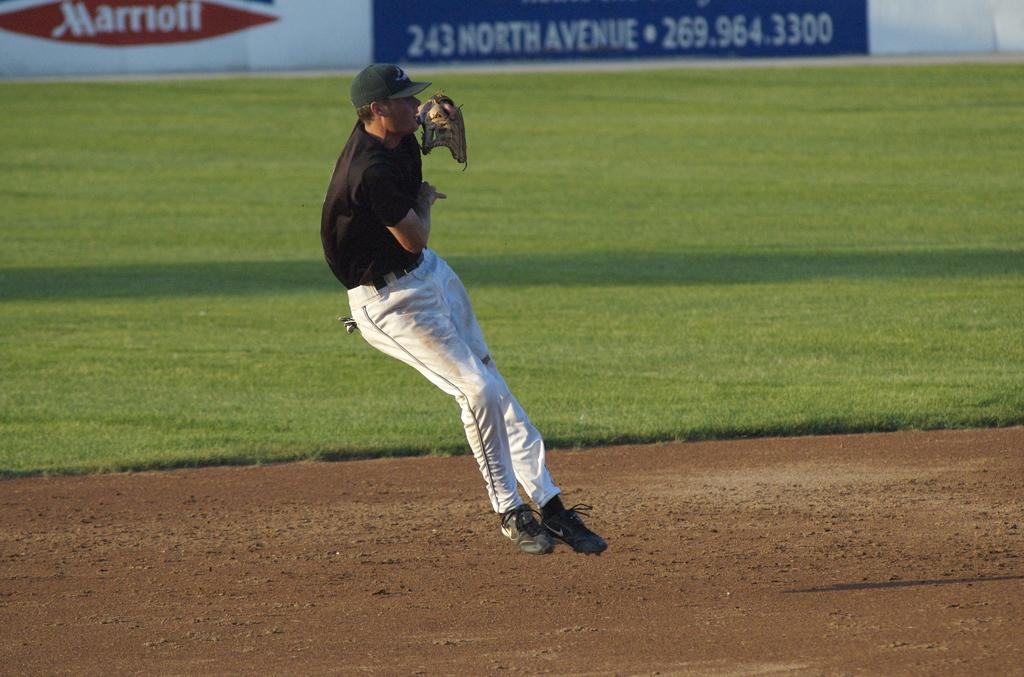What's the phone number?
Your answer should be very brief. 269.964.3300. What is the phone number shown on the ad?
Offer a terse response. 269.964.3300. 